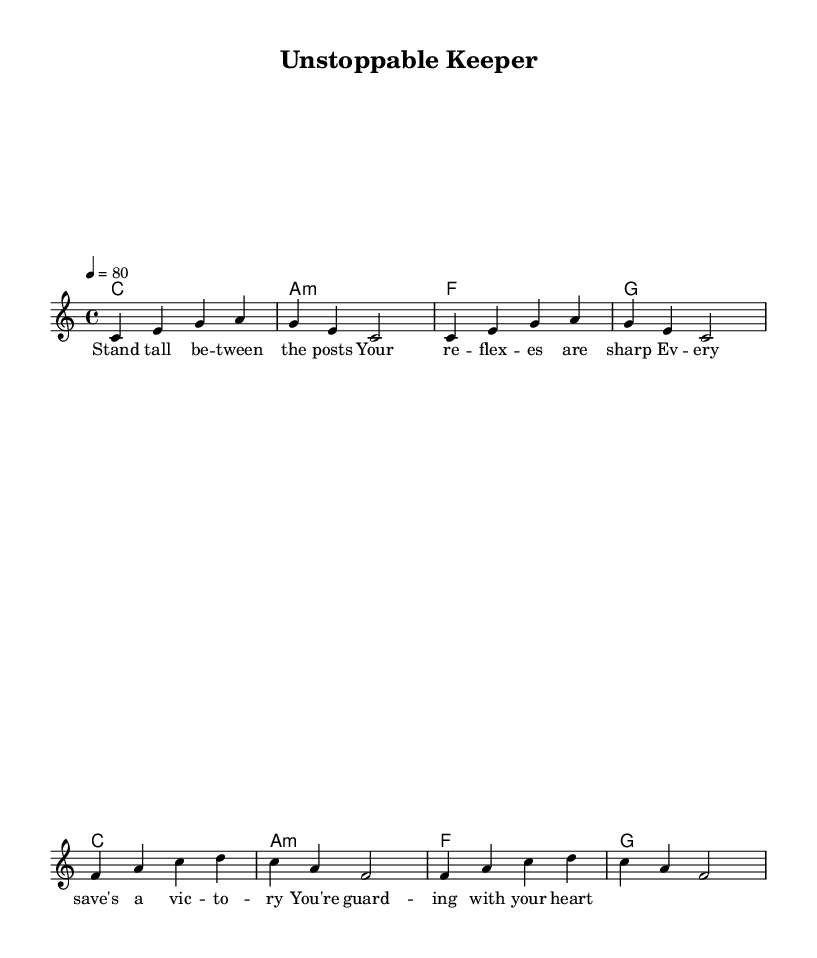What is the key signature of this music? The key signature is C major, which has no sharps or flats.
Answer: C major What is the time signature of this music? The time signature is indicated at the beginning and shows that there are 4 beats in each measure.
Answer: 4/4 What is the tempo marking in this sheet music? The tempo marking states '4 = 80,' which indicates the speed of the music at 80 beats per minute.
Answer: 80 How many measures are in the melody section? By counting the measures in the melody part, there are 8 measures present in total.
Answer: 8 Which chord follows the C major chord in the harmony? The harmony sequence shows that after the C major chord, the next chord is A minor.
Answer: A minor What is the motivational theme presented in the lyrics? The lyrics emphasize standing strong and being determined while guarding the goal, which aligns with a motivational theme for athletes.
Answer: Determination What genre does this music belong to? The style and rhythmic patterns, along with the lyrical content focused on perseverance, categorize this piece as Reggae music.
Answer: Reggae 